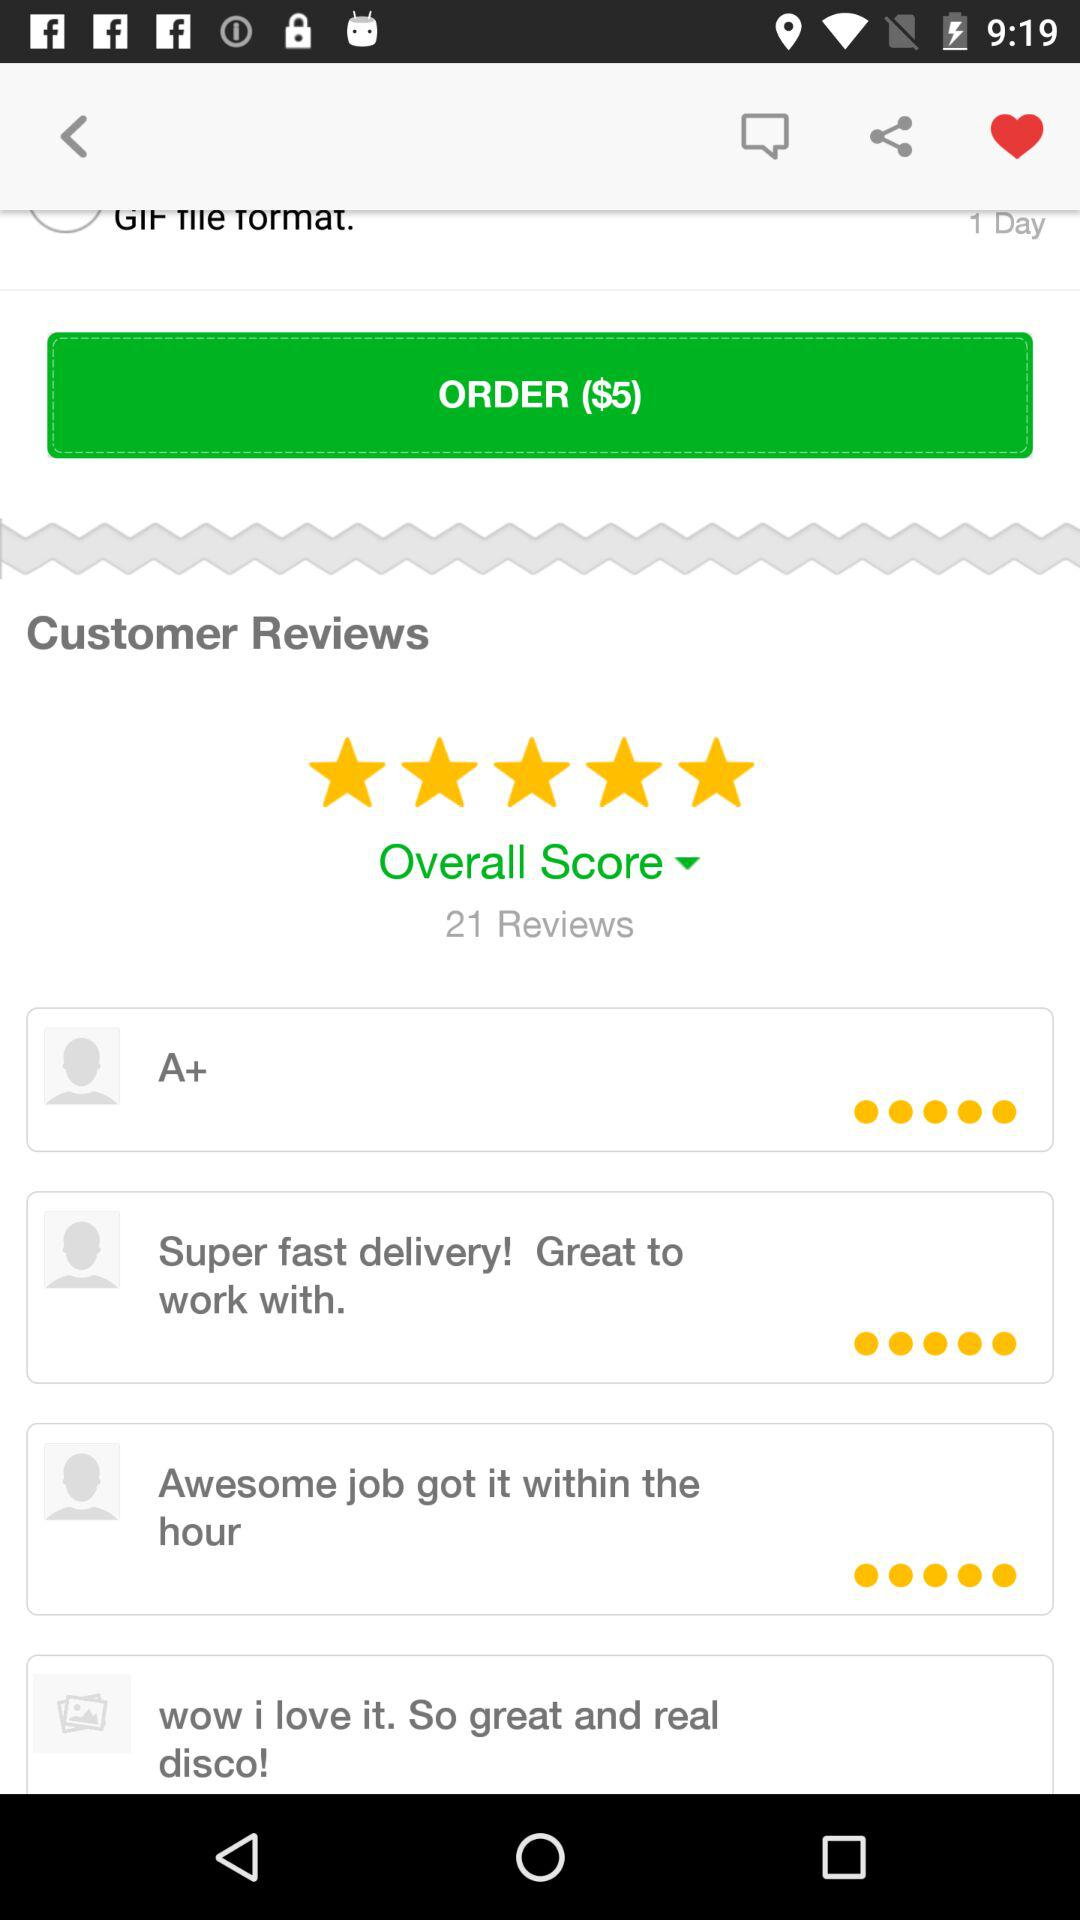What is the currency for the "Order"? The currency is $. 